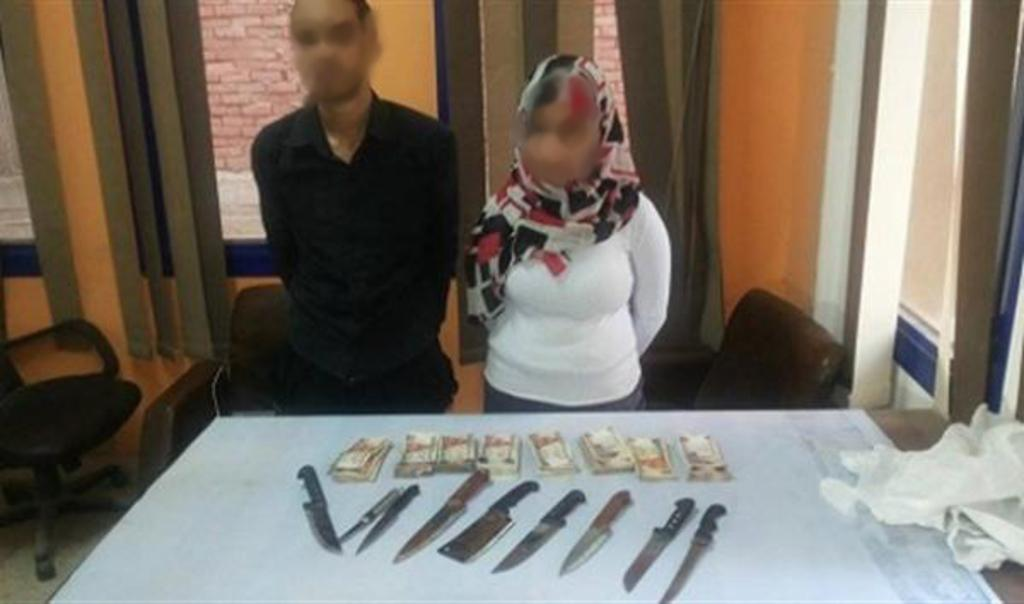How many people are present in the image? There is a man and a woman in the image. What are they doing in the image? They are standing in front of a table. What can be seen on the table? There is cash and knives on the table. What is located behind the table? There are chairs behind the table. What is visible on the wall? There is a window on the wall. What type of window treatment is present? There are curtains associated with the window. What type of bread is being served on the side in the image? There is no bread present in the image. What type of cloth is draped over the chairs in the image? There is no cloth draped over the chairs in the image. 